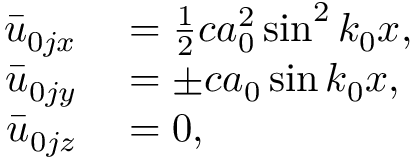Convert formula to latex. <formula><loc_0><loc_0><loc_500><loc_500>\begin{array} { r l } { \bar { u } _ { 0 j x } } & = \frac { 1 } { 2 } c a _ { 0 } ^ { 2 } \sin ^ { 2 } { k _ { 0 } x } , } \\ { \bar { u } _ { 0 j y } } & = \pm c a _ { 0 } \sin { k _ { 0 } x } , } \\ { \bar { u } _ { 0 j z } } & = 0 , } \end{array}</formula> 